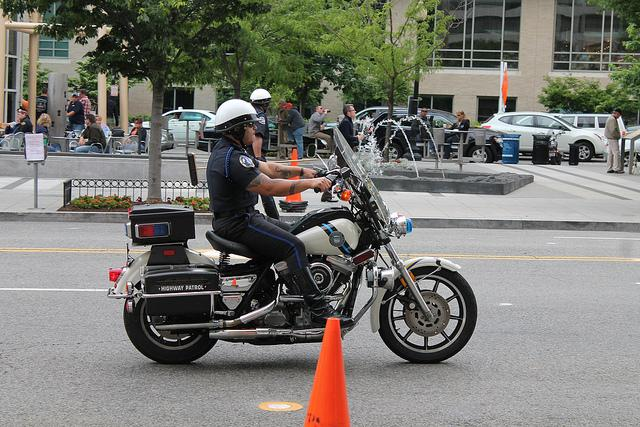Where is the officer riding here? street 